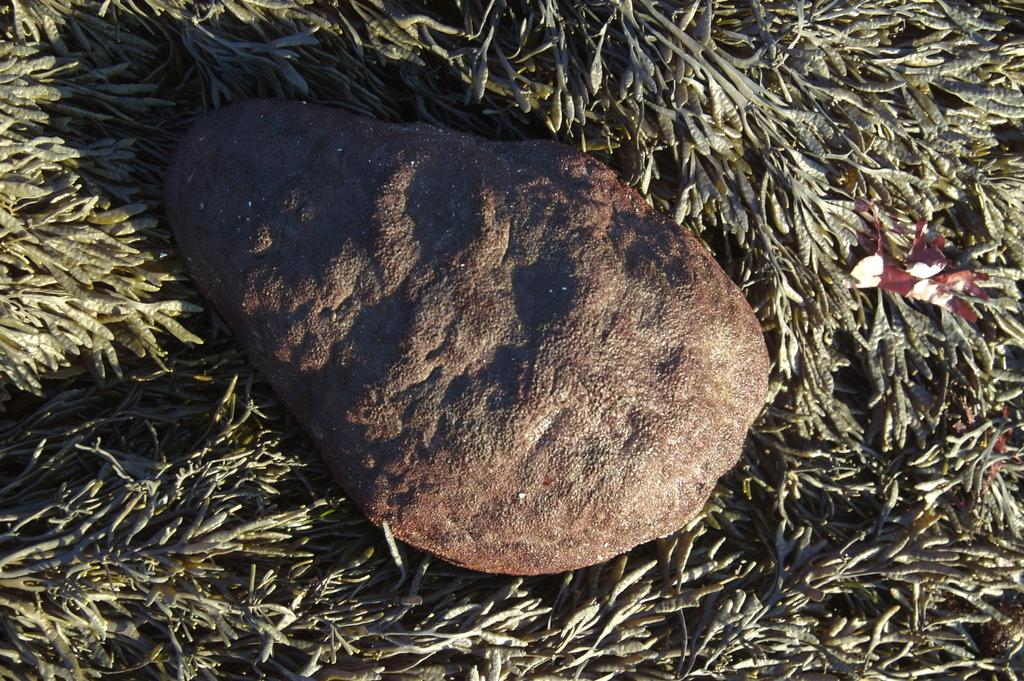What is the main subject of the image? The main subject of the image is a rock. Can you describe the surface on which the rock is placed? The rock is on a grassy surface. What type of behavior can be observed in the rock in the image? Rocks do not exhibit behavior, so this question cannot be answered based on the image. 